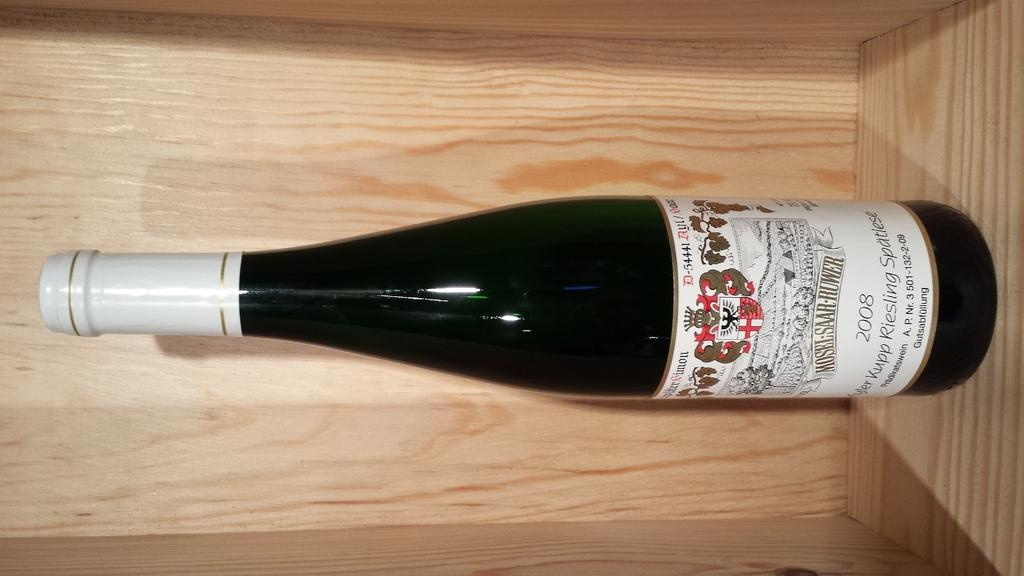<image>
Summarize the visual content of the image. A bottle of 2008 Riesling wine by Mosel-Saar-Ruwer. 